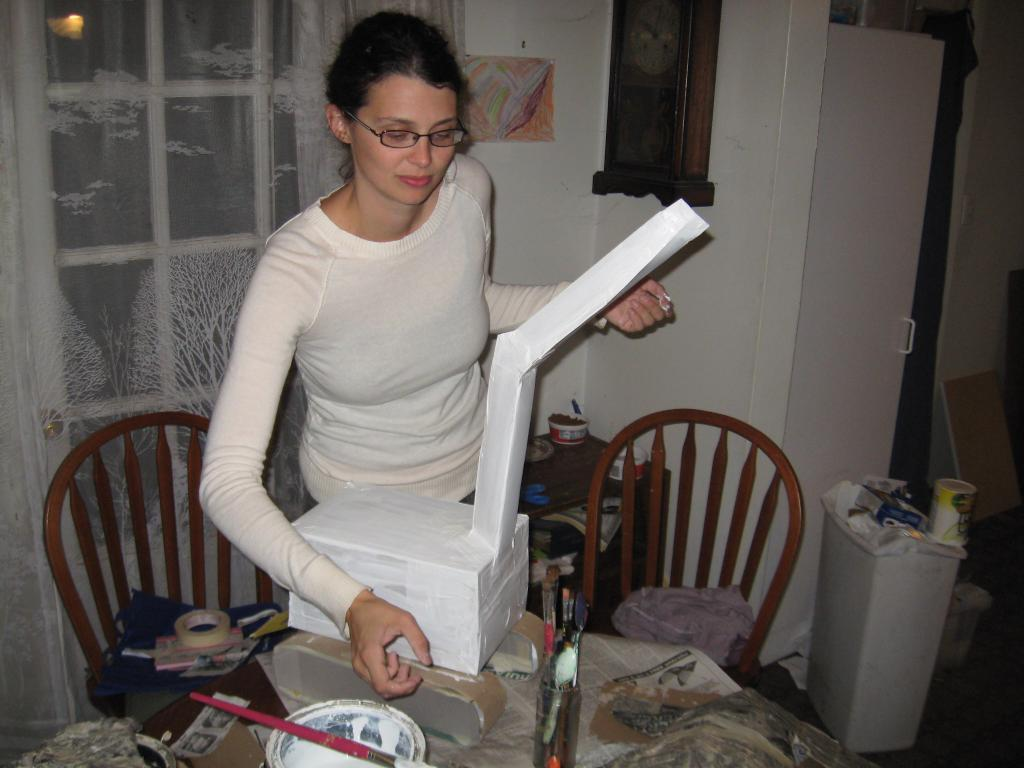What is the color of the wall in the image? The wall in the image is white. What can be seen on the wall in the image? There is a window on the wall in the image. Who is present in the image? There is a woman standing in the image. What type of furniture is visible in the image? There are chairs and tables in the image. What is placed on the table in the image? There is a box on the table in the image. What is the weight of the marble in the image? There is no marble present in the image, so it is not possible to determine its weight. 